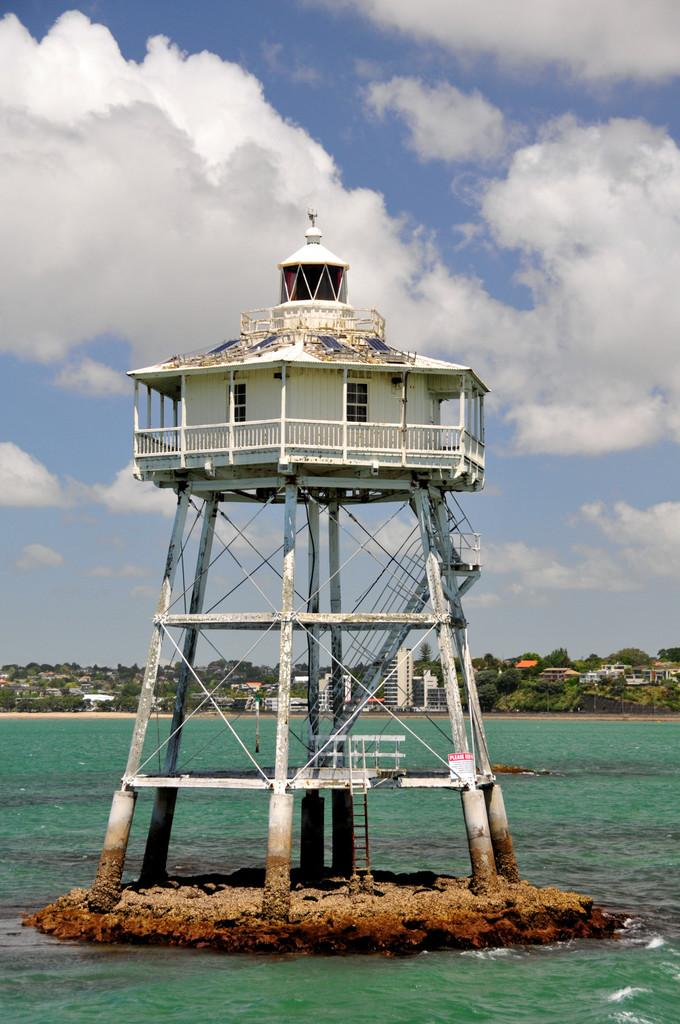What type of environment is depicted in the image? The image shows a combination of water and sand, suggesting a beach or coastal area. What object is present in the image that is related to water? There is a water tanker in the image. What can be seen in the background of the image? There are trees and houses in the background, as well as clouds in the sky. What type of natural vegetation is visible in the image? Trees are visible in the background of the image. What is the value of the brass sculpture in the image? There is no brass sculpture present in the image. How does the water attack the sand in the image? The water does not attack the sand in the image; it is a natural occurrence at a beach or coastal area. 